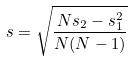Convert formula to latex. <formula><loc_0><loc_0><loc_500><loc_500>s = \sqrt { \frac { N s _ { 2 } - s _ { 1 } ^ { 2 } } { N ( N - 1 ) } }</formula> 